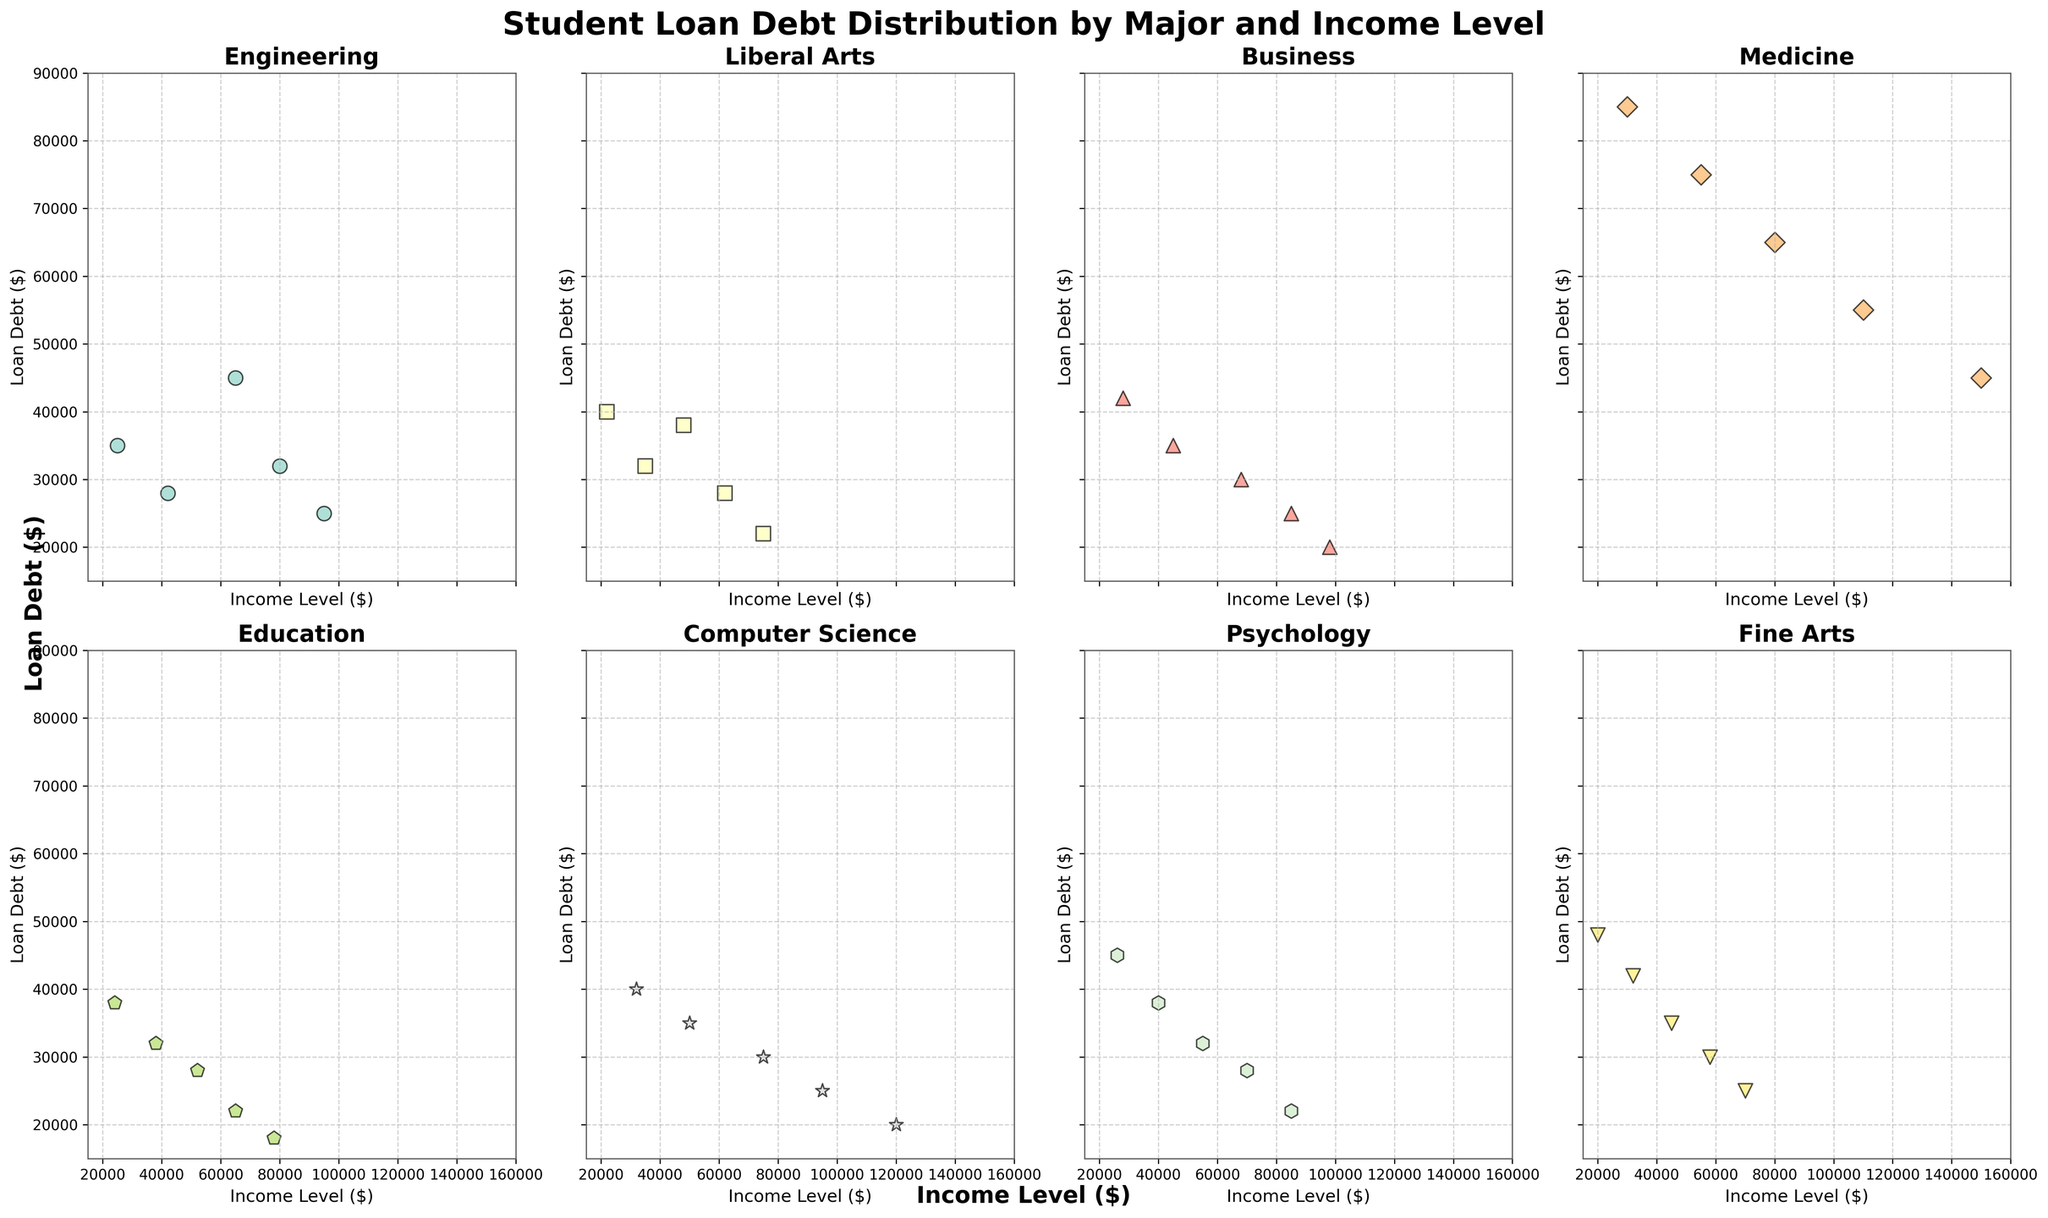Which major has the highest student loan debt for an income level of $30,000? The Medicine subplot shows the highest student loan debt at an income level of $30,000. This can be seen by comparing the student loan debt for $30,000 across all majors, with Medicine being the highest.
Answer: Medicine Which major's student loan debt shows the steepest decline as income level increases? The Liberal Arts subplot shows a clear, steep decline in student loan debt as income level increases compared to other majors. This can be observed as the points on the plot form a descending pattern.
Answer: Liberal Arts For people earning $70,000, which major has the lowest loan debt? By looking at the subplots for each major where Income Level is $70,000, the Psychology major shows the student loan debt to be the lowest among all majors.
Answer: Psychology What can be said about the relationship between income level and student loan debt for Computer Science majors? The plot for Computer Science shows a downward trend in student loan debt as income level increases. This suggests that as Computer Science majors earn more, their student loan debt tends to decrease.
Answer: As income increases, loan debt decreases Considering Engineering and Business majors at $80,000 income level, who has more loan debt? By comparing the scatter points for $80,000 income level for both Engineering and Business, it can be seen that the Engineering major has more student loan debt than Business.
Answer: Engineering Which major has the maximum range in student loan debt across different income levels? Observing the span of student loan debts within each subplot, Medicine has the largest range, varying from $85,000 to $45,000, indicating the maximum fluctuation in loan debt across different income levels.
Answer: Medicine Are there any majors where student loan debt does not show significant fluctuation with income level? Education majors seem to have a relatively stable pattern with lower fluctuations in student loan debt across different income levels, indicating a lack of significant variation.
Answer: Education At an income level of $100,000, which major appears to have the least student loan debt, and what is the debt amount? For an income level of $100,000, Business and Computer Science majors both show student loan debts closest to $20,000, with Computer Science being slightly lower.
Answer: Computer Science, around $20,000 